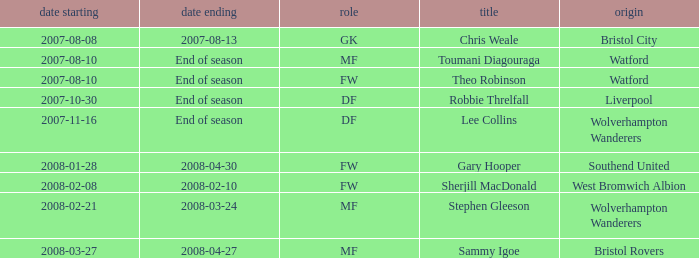What was the from for the Date From of 2007-08-08? Bristol City. 